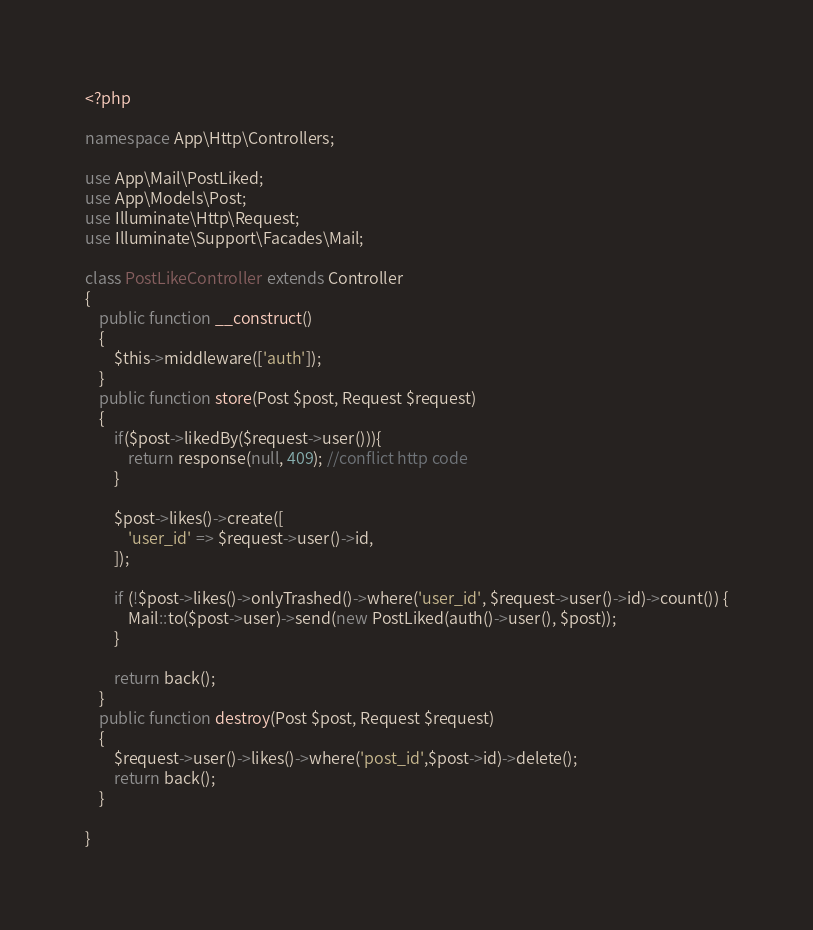<code> <loc_0><loc_0><loc_500><loc_500><_PHP_><?php

namespace App\Http\Controllers;

use App\Mail\PostLiked;
use App\Models\Post;
use Illuminate\Http\Request;
use Illuminate\Support\Facades\Mail;

class PostLikeController extends Controller
{
    public function __construct()
    {
        $this->middleware(['auth']);
    }
    public function store(Post $post, Request $request)
    {
        if($post->likedBy($request->user())){
            return response(null, 409); //conflict http code
        }

        $post->likes()->create([
            'user_id' => $request->user()->id,
        ]);

        if (!$post->likes()->onlyTrashed()->where('user_id', $request->user()->id)->count()) {
            Mail::to($post->user)->send(new PostLiked(auth()->user(), $post));
        }

        return back();
    }
    public function destroy(Post $post, Request $request)
    {
        $request->user()->likes()->where('post_id',$post->id)->delete();
        return back();
    }

}
</code> 